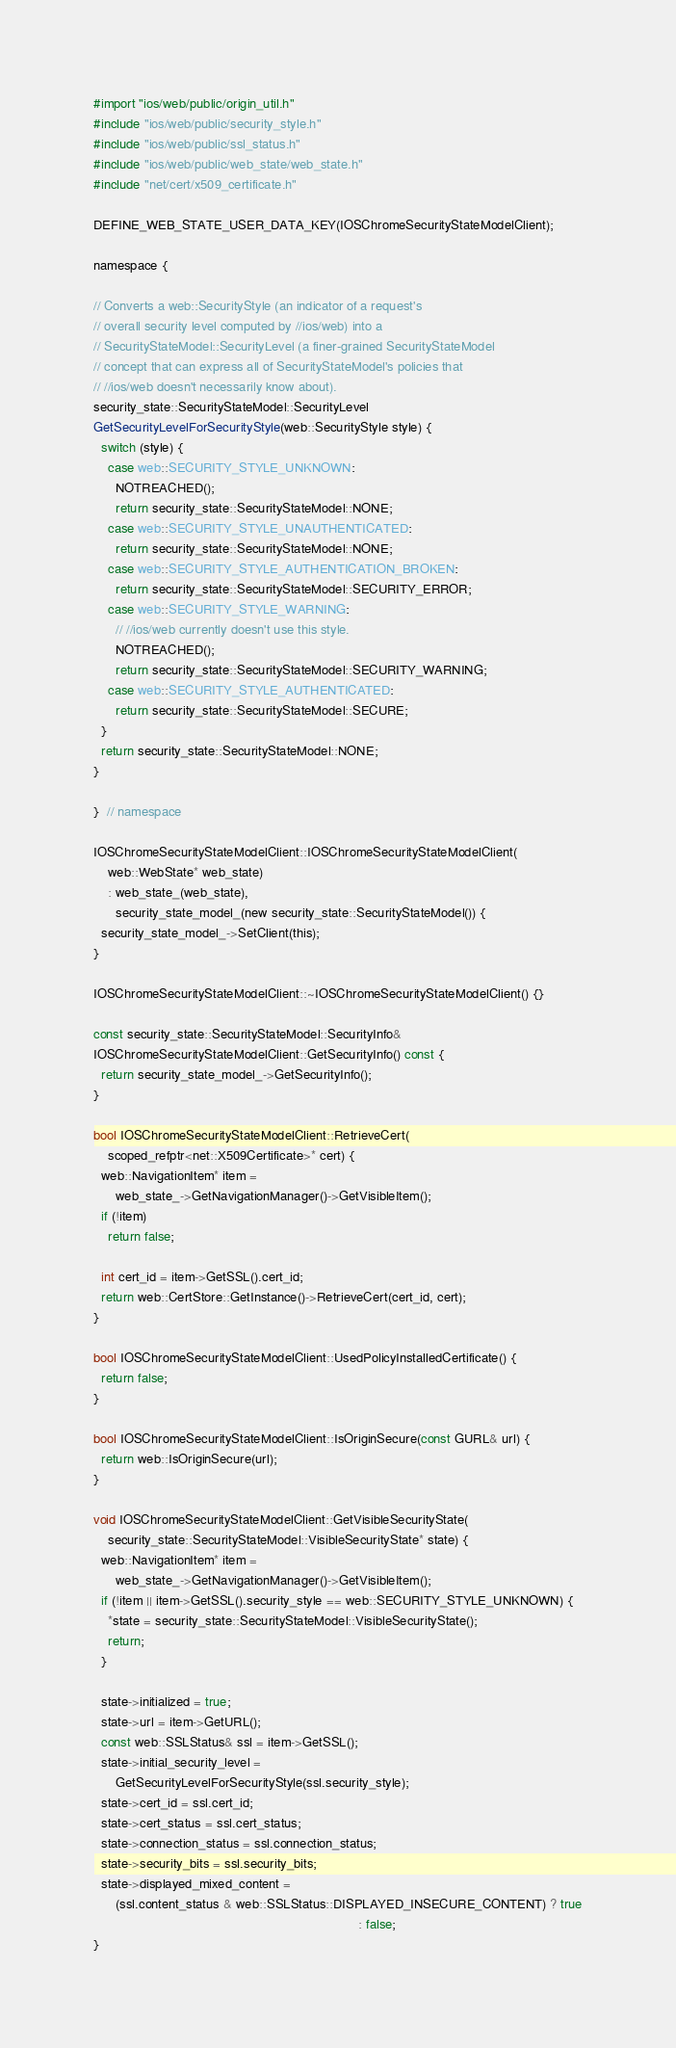Convert code to text. <code><loc_0><loc_0><loc_500><loc_500><_ObjectiveC_>#import "ios/web/public/origin_util.h"
#include "ios/web/public/security_style.h"
#include "ios/web/public/ssl_status.h"
#include "ios/web/public/web_state/web_state.h"
#include "net/cert/x509_certificate.h"

DEFINE_WEB_STATE_USER_DATA_KEY(IOSChromeSecurityStateModelClient);

namespace {

// Converts a web::SecurityStyle (an indicator of a request's
// overall security level computed by //ios/web) into a
// SecurityStateModel::SecurityLevel (a finer-grained SecurityStateModel
// concept that can express all of SecurityStateModel's policies that
// //ios/web doesn't necessarily know about).
security_state::SecurityStateModel::SecurityLevel
GetSecurityLevelForSecurityStyle(web::SecurityStyle style) {
  switch (style) {
    case web::SECURITY_STYLE_UNKNOWN:
      NOTREACHED();
      return security_state::SecurityStateModel::NONE;
    case web::SECURITY_STYLE_UNAUTHENTICATED:
      return security_state::SecurityStateModel::NONE;
    case web::SECURITY_STYLE_AUTHENTICATION_BROKEN:
      return security_state::SecurityStateModel::SECURITY_ERROR;
    case web::SECURITY_STYLE_WARNING:
      // //ios/web currently doesn't use this style.
      NOTREACHED();
      return security_state::SecurityStateModel::SECURITY_WARNING;
    case web::SECURITY_STYLE_AUTHENTICATED:
      return security_state::SecurityStateModel::SECURE;
  }
  return security_state::SecurityStateModel::NONE;
}

}  // namespace

IOSChromeSecurityStateModelClient::IOSChromeSecurityStateModelClient(
    web::WebState* web_state)
    : web_state_(web_state),
      security_state_model_(new security_state::SecurityStateModel()) {
  security_state_model_->SetClient(this);
}

IOSChromeSecurityStateModelClient::~IOSChromeSecurityStateModelClient() {}

const security_state::SecurityStateModel::SecurityInfo&
IOSChromeSecurityStateModelClient::GetSecurityInfo() const {
  return security_state_model_->GetSecurityInfo();
}

bool IOSChromeSecurityStateModelClient::RetrieveCert(
    scoped_refptr<net::X509Certificate>* cert) {
  web::NavigationItem* item =
      web_state_->GetNavigationManager()->GetVisibleItem();
  if (!item)
    return false;

  int cert_id = item->GetSSL().cert_id;
  return web::CertStore::GetInstance()->RetrieveCert(cert_id, cert);
}

bool IOSChromeSecurityStateModelClient::UsedPolicyInstalledCertificate() {
  return false;
}

bool IOSChromeSecurityStateModelClient::IsOriginSecure(const GURL& url) {
  return web::IsOriginSecure(url);
}

void IOSChromeSecurityStateModelClient::GetVisibleSecurityState(
    security_state::SecurityStateModel::VisibleSecurityState* state) {
  web::NavigationItem* item =
      web_state_->GetNavigationManager()->GetVisibleItem();
  if (!item || item->GetSSL().security_style == web::SECURITY_STYLE_UNKNOWN) {
    *state = security_state::SecurityStateModel::VisibleSecurityState();
    return;
  }

  state->initialized = true;
  state->url = item->GetURL();
  const web::SSLStatus& ssl = item->GetSSL();
  state->initial_security_level =
      GetSecurityLevelForSecurityStyle(ssl.security_style);
  state->cert_id = ssl.cert_id;
  state->cert_status = ssl.cert_status;
  state->connection_status = ssl.connection_status;
  state->security_bits = ssl.security_bits;
  state->displayed_mixed_content =
      (ssl.content_status & web::SSLStatus::DISPLAYED_INSECURE_CONTENT) ? true
                                                                        : false;
}
</code> 